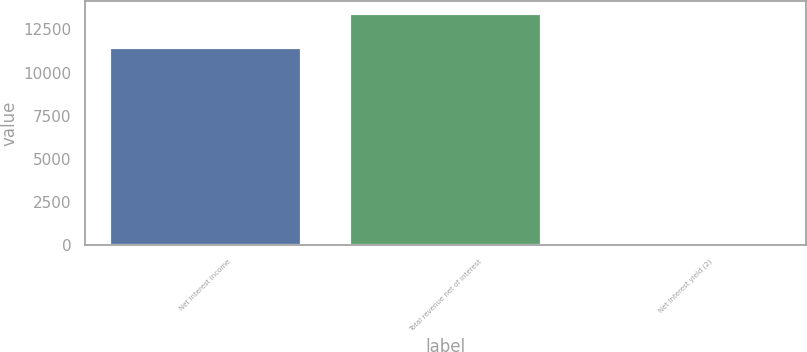Convert chart to OTSL. <chart><loc_0><loc_0><loc_500><loc_500><bar_chart><fcel>Net interest income<fcel>Total revenue net of interest<fcel>Net interest yield (2)<nl><fcel>11493<fcel>13483<fcel>2.5<nl></chart> 